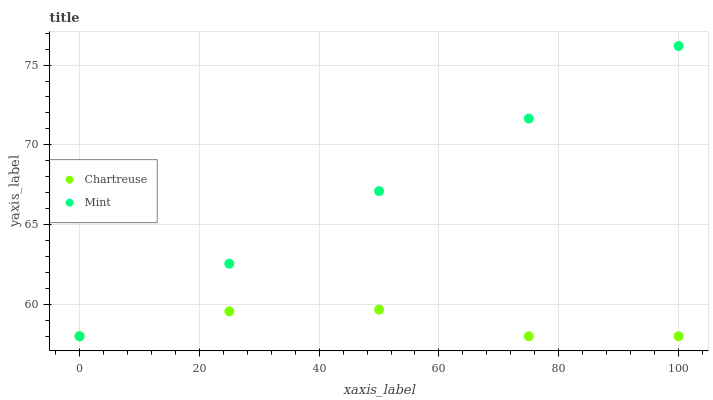Does Chartreuse have the minimum area under the curve?
Answer yes or no. Yes. Does Mint have the maximum area under the curve?
Answer yes or no. Yes. Does Mint have the minimum area under the curve?
Answer yes or no. No. Is Mint the smoothest?
Answer yes or no. Yes. Is Chartreuse the roughest?
Answer yes or no. Yes. Is Mint the roughest?
Answer yes or no. No. Does Chartreuse have the lowest value?
Answer yes or no. Yes. Does Mint have the highest value?
Answer yes or no. Yes. Does Mint intersect Chartreuse?
Answer yes or no. Yes. Is Mint less than Chartreuse?
Answer yes or no. No. Is Mint greater than Chartreuse?
Answer yes or no. No. 